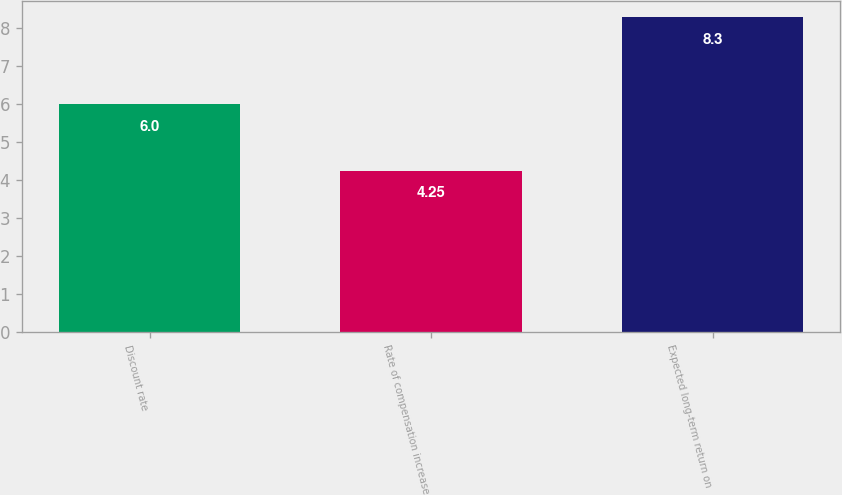Convert chart. <chart><loc_0><loc_0><loc_500><loc_500><bar_chart><fcel>Discount rate<fcel>Rate of compensation increase<fcel>Expected long-term return on<nl><fcel>6<fcel>4.25<fcel>8.3<nl></chart> 